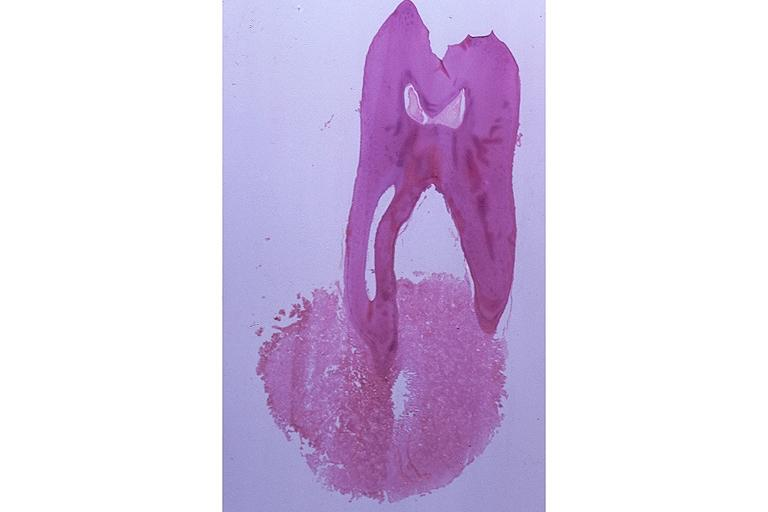s oral present?
Answer the question using a single word or phrase. Yes 